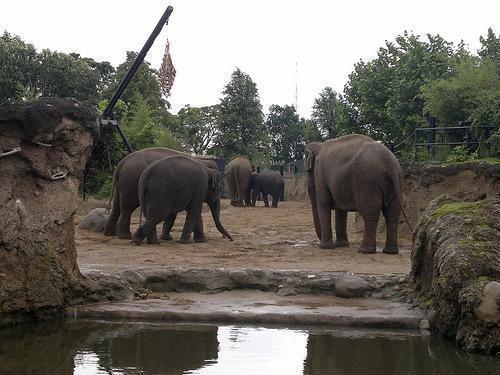How many elephants are there?
Give a very brief answer. 5. 